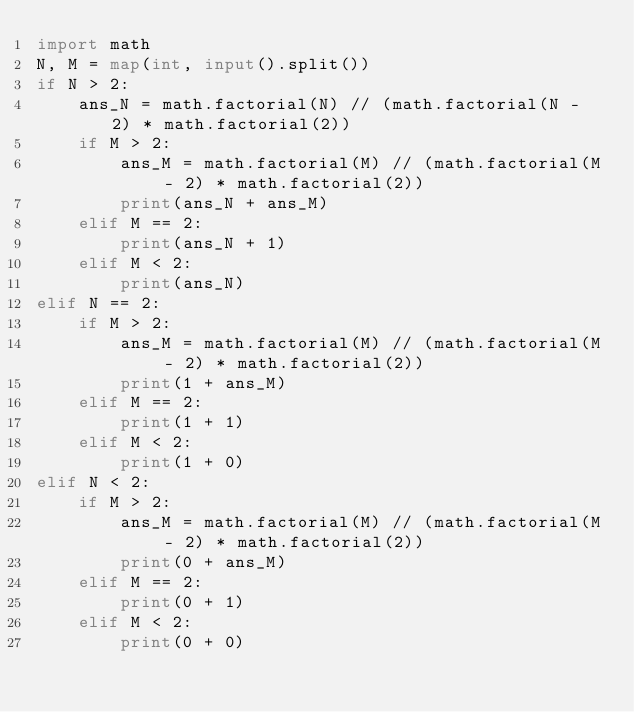<code> <loc_0><loc_0><loc_500><loc_500><_Python_>import math
N, M = map(int, input().split())
if N > 2:
    ans_N = math.factorial(N) // (math.factorial(N - 2) * math.factorial(2))
    if M > 2:
        ans_M = math.factorial(M) // (math.factorial(M - 2) * math.factorial(2))
        print(ans_N + ans_M)
    elif M == 2:
        print(ans_N + 1)
    elif M < 2:
        print(ans_N)
elif N == 2:
    if M > 2:
        ans_M = math.factorial(M) // (math.factorial(M - 2) * math.factorial(2))
        print(1 + ans_M)
    elif M == 2:
        print(1 + 1)
    elif M < 2:
        print(1 + 0)
elif N < 2:
    if M > 2:
        ans_M = math.factorial(M) // (math.factorial(M - 2) * math.factorial(2))
        print(0 + ans_M)
    elif M == 2:
        print(0 + 1)
    elif M < 2:
        print(0 + 0)</code> 